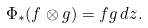<formula> <loc_0><loc_0><loc_500><loc_500>\Phi _ { * } ( f \otimes g ) = f g \, d z .</formula> 